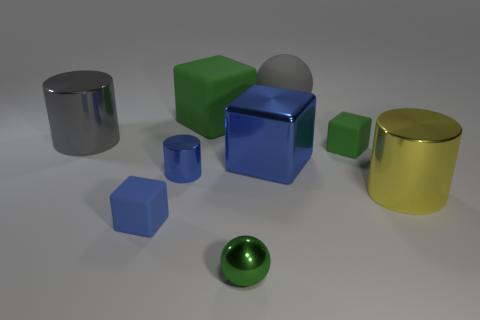What size is the green rubber object that is behind the big gray shiny cylinder?
Make the answer very short. Large. What is the big blue cube made of?
Ensure brevity in your answer.  Metal. What number of objects are either big rubber things that are left of the gray rubber ball or large cylinders that are to the right of the gray ball?
Ensure brevity in your answer.  2. What number of other objects are the same color as the large rubber block?
Give a very brief answer. 2. Do the large gray matte thing and the big metal object right of the gray rubber object have the same shape?
Provide a succinct answer. No. Are there fewer tiny shiny objects that are behind the tiny shiny ball than large gray cylinders behind the big matte block?
Your answer should be very brief. No. There is another small object that is the same shape as the tiny green rubber thing; what material is it?
Provide a succinct answer. Rubber. Are there any other things that are made of the same material as the small blue cube?
Provide a short and direct response. Yes. Is the color of the big rubber block the same as the small shiny cylinder?
Your answer should be very brief. No. There is a yellow object that is made of the same material as the gray cylinder; what shape is it?
Your answer should be very brief. Cylinder. 